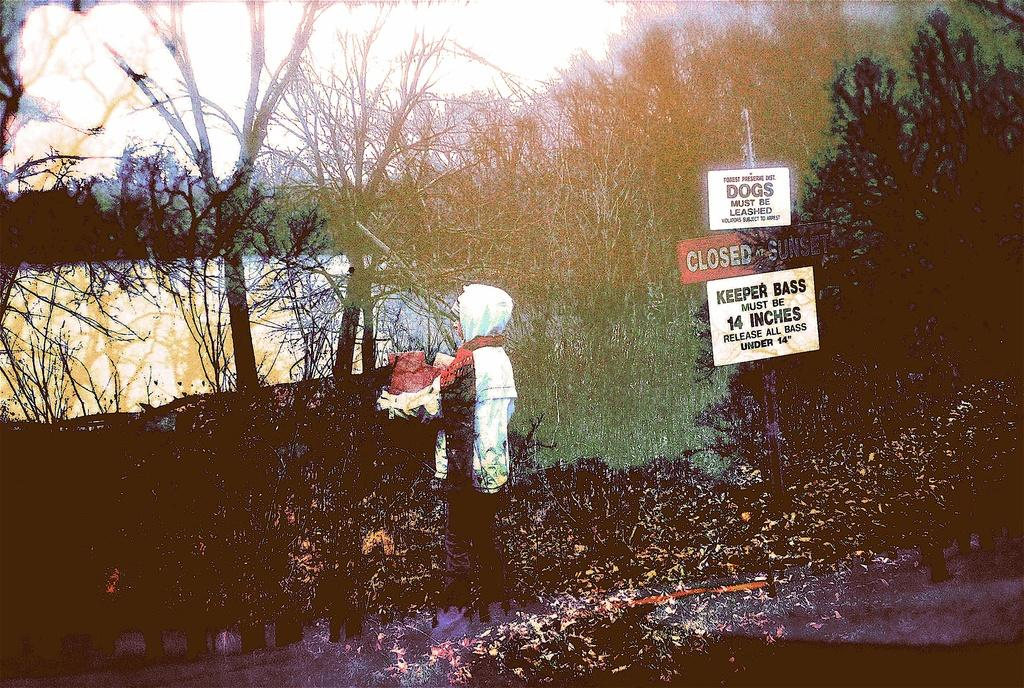Who or what is the main subject in the image? There is a person in the image. What can be seen on the right side of the image? There are boards with text on the right side of the image. What type of natural scenery is visible in the background of the image? There are trees in the background of the image. What type of goldfish can be seen swimming in the text on the boards? There are no goldfish present in the image; the boards contain text, not aquatic creatures. 